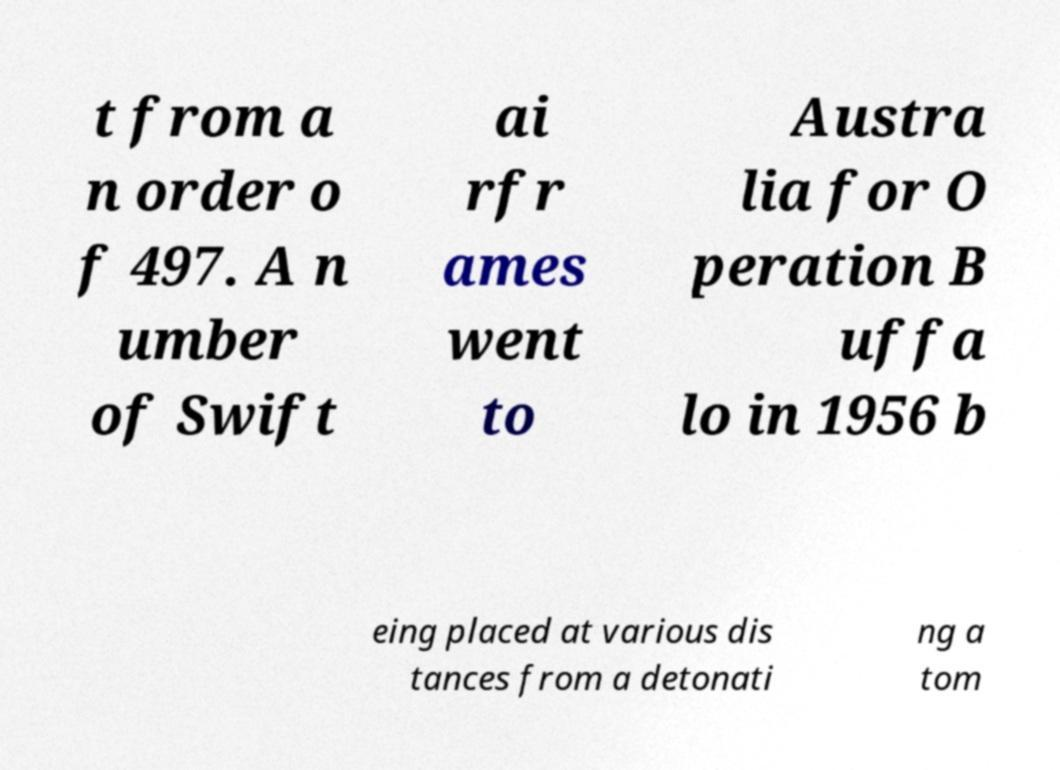Please identify and transcribe the text found in this image. t from a n order o f 497. A n umber of Swift ai rfr ames went to Austra lia for O peration B uffa lo in 1956 b eing placed at various dis tances from a detonati ng a tom 